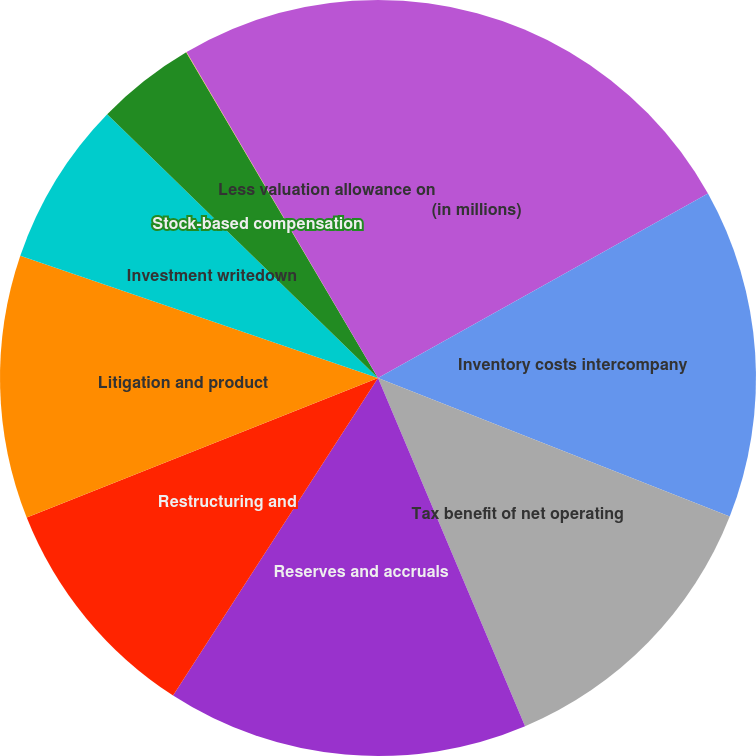Convert chart. <chart><loc_0><loc_0><loc_500><loc_500><pie_chart><fcel>(in millions)<fcel>Inventory costs intercompany<fcel>Tax benefit of net operating<fcel>Reserves and accruals<fcel>Restructuring and<fcel>Litigation and product<fcel>Investment writedown<fcel>Stock-based compensation<fcel>Other<fcel>Less valuation allowance on<nl><fcel>16.89%<fcel>14.08%<fcel>12.67%<fcel>15.48%<fcel>9.86%<fcel>11.26%<fcel>7.05%<fcel>4.24%<fcel>0.02%<fcel>8.45%<nl></chart> 